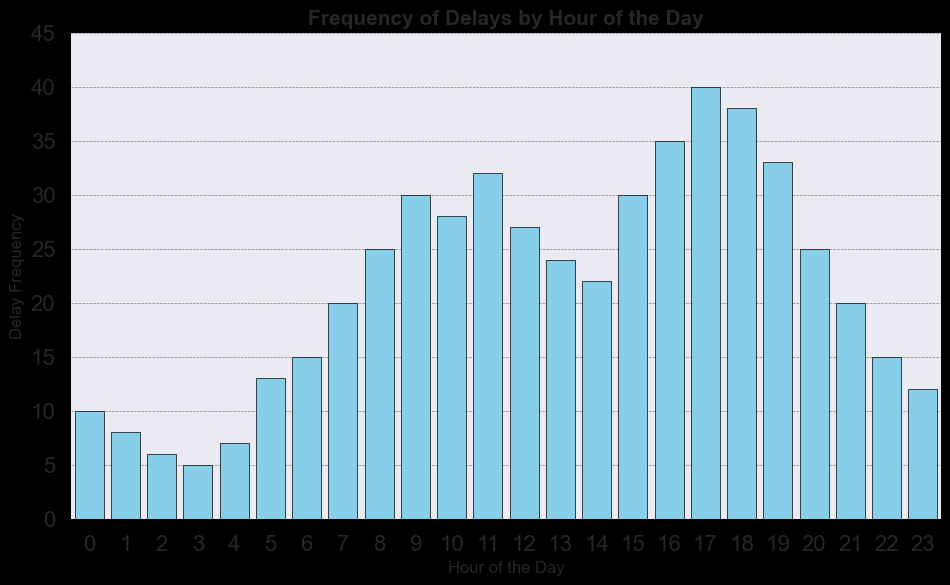Which hour has the highest frequency of delays? Observe the bar heights in the histogram. The tallest bar represents the highest frequency. The hour with the tallest bar corresponds to hour 17.
Answer: 17 What is the difference in delay frequency between hour 9 and hour 16? Find the heights of the bars at hours 9 and 16. Hour 9 has a frequency of 30, and hour 16 has a frequency of 35. The difference is 35 - 30.
Answer: 5 During which hours is the delay frequency exactly 25? Check the bar heights and find the ones that align with a frequency of 25. These bars correspond to hours 8 and 20.
Answer: 8, 20 What is the total delay frequency from hours 0 to 2? Sum the frequencies at hours 0, 1, and 2. These are: 10 + 8 + 6.
Answer: 24 Is the delay frequency higher at hour 4 or hour 5? Compare the bar heights at hours 4 and 5. Hour 4 has a frequency of 7, and hour 5 has a frequency of 13.
Answer: Hour 5 How many hours have a delay frequency greater than 30? Count the bars with heights above 30. The hours with frequencies greater than 30 are 11, 16, 17, 18, and 19, which sum up to 5 hours.
Answer: 5 What is the average delay frequency between hours 10 and 14? Calculate the average of the frequencies at hours 10, 11, 12, 13, and 14. These are: (28 + 32 + 27 + 24 + 22) / 5, which equates to 133/5.
Answer: 26.6 Identify the color of the bars in the histogram. Observe the visual elements of the histogram. The bars are colored 'skyblue'.
Answer: skyblue What is the range of delay frequencies shown in the histogram? Identify the minimum and maximum values of the bars. The minimum frequency is 5 (hour 3), and the maximum frequency is 40 (hour 17). The range is 40 - 5.
Answer: 35 